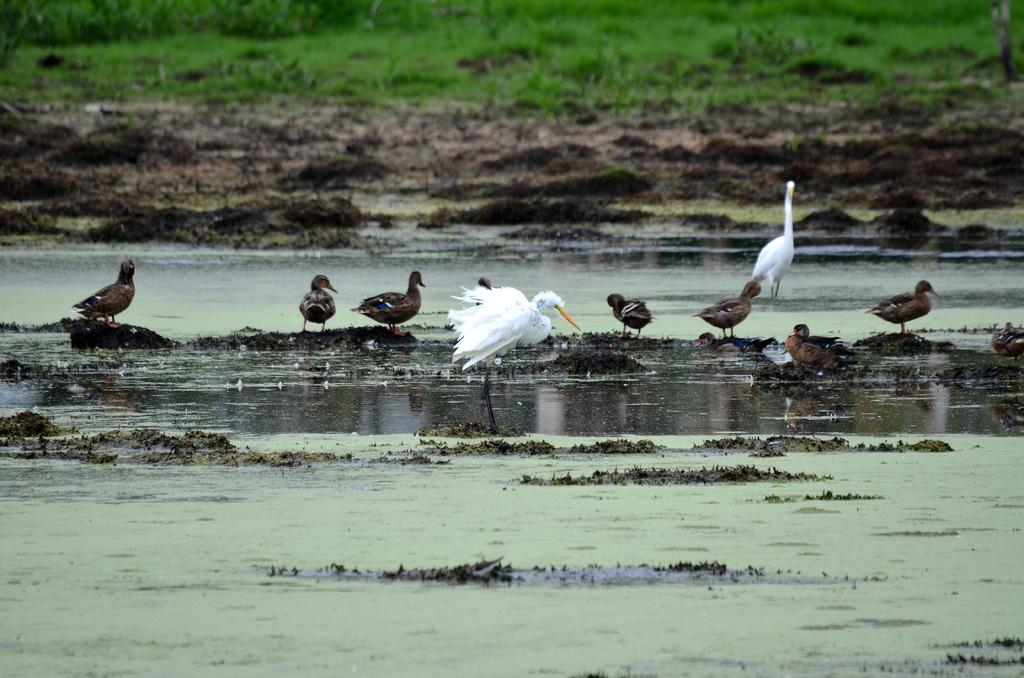What type of animals can be seen in the image? There are birds in the image. Where are the birds located in the image? The birds are standing in the mud and water. What type of vegetation is visible in the image? There is grass visible in the image behind the birds. What type of caption is written on the grass in the image? There is no caption written on the grass in the image. How is the glue used in the image? There is no glue present in the image. 